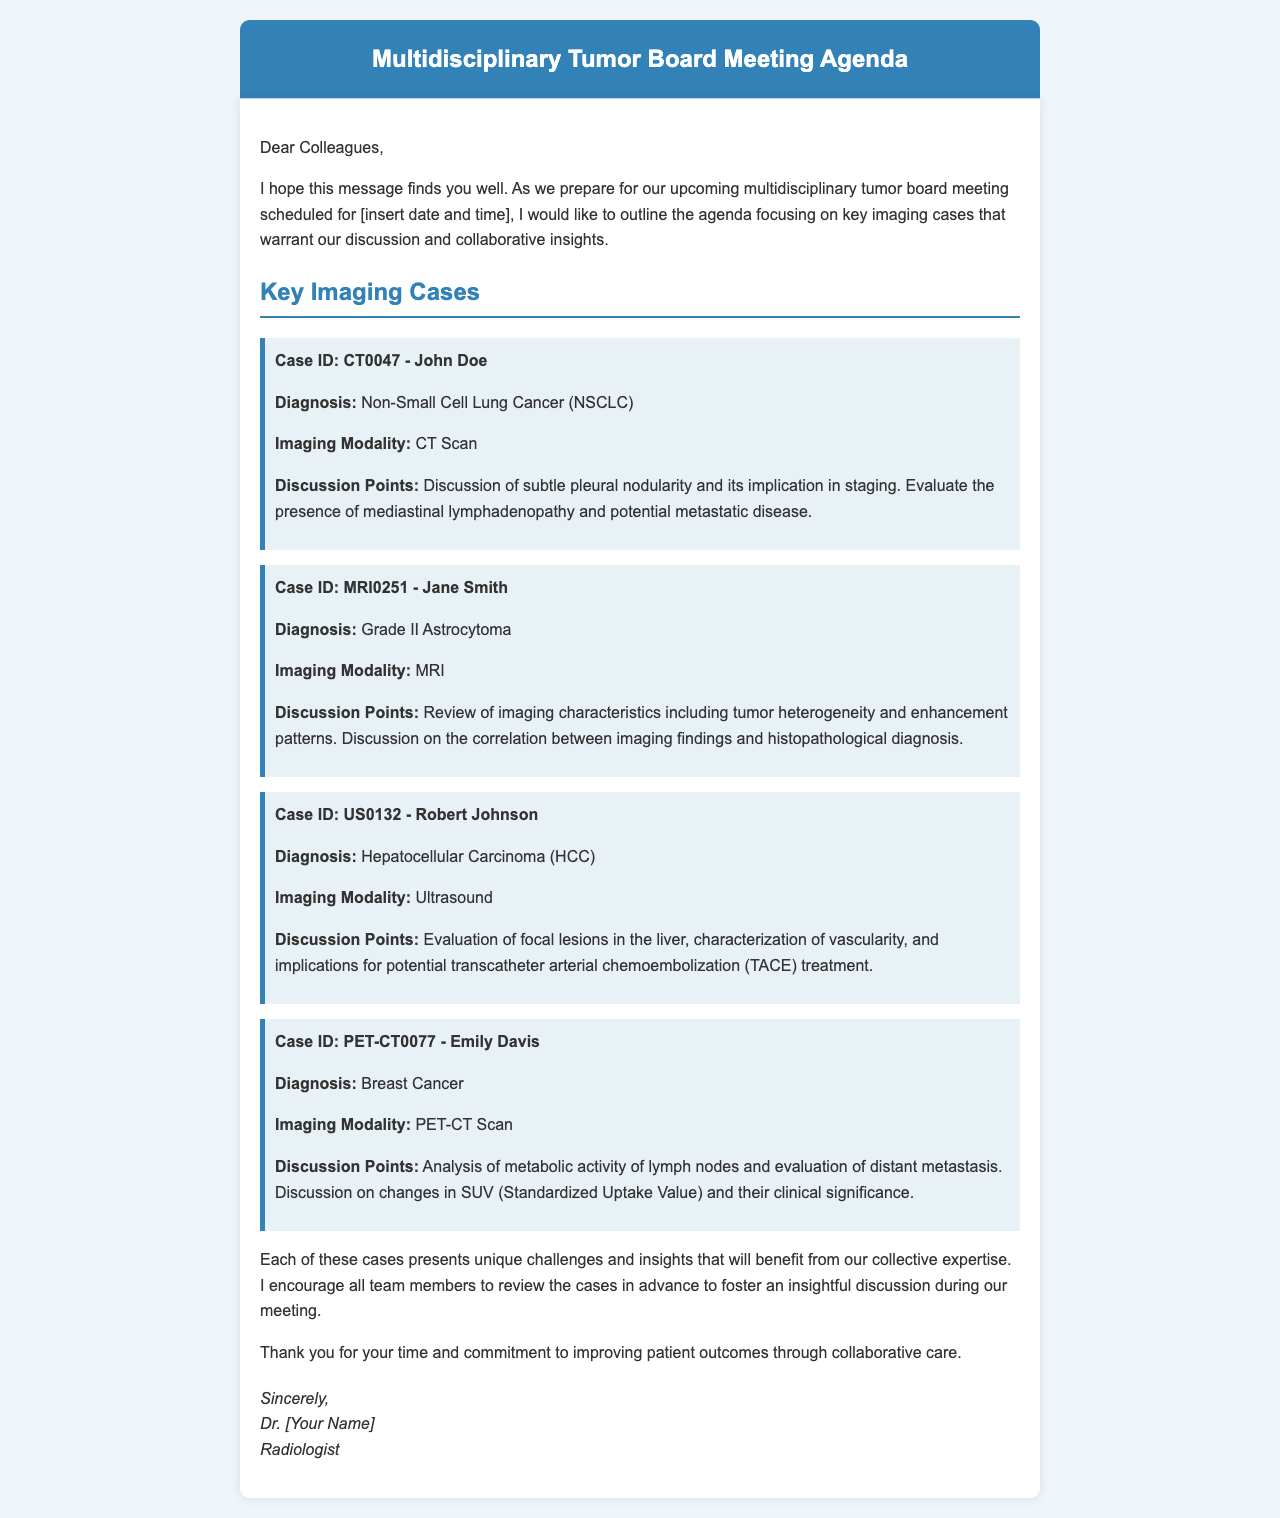What is the date and time of the meeting? The date and time of the meeting are mentioned at the beginning of the letter but are indicated as [insert date and time]; therefore, it is not specified.
Answer: Not specified What is the diagnosis for Case ID CT0047? The diagnosis for Case ID CT0047 is provided in the document as Non-Small Cell Lung Cancer.
Answer: Non-Small Cell Lung Cancer What imaging modality is used for the first case? The imaging modality for the first case (Case ID CT0047) is listed as a CT Scan.
Answer: CT Scan What are the discussion points for Case ID MRI0251? The discussion points for Case ID MRI0251 include imaging characteristics, tumor heterogeneity, enhancement patterns, and correlation with histopathology.
Answer: Imaging characteristics, tumor heterogeneity, and enhancement patterns Which patient has Hepatocellular Carcinoma? The patient with Hepatocellular Carcinoma is Robert Johnson, who is mentioned in the letter as Case ID US0132.
Answer: Robert Johnson What does SUV stand for in the context of the PET-CT analysis? SUV is referenced in the context of PET-CT, standing for Standardized Uptake Value, which relates to the discussion points listed.
Answer: Standardized Uptake Value How many key imaging cases are highlighted in the document? The document highlights a total of four key imaging cases during the multidisciplinary tumor board meeting.
Answer: Four What is the role of Dr. [Your Name]? The role of Dr. [Your Name] is described as a Radiologist in the signature section of the document.
Answer: Radiologist 